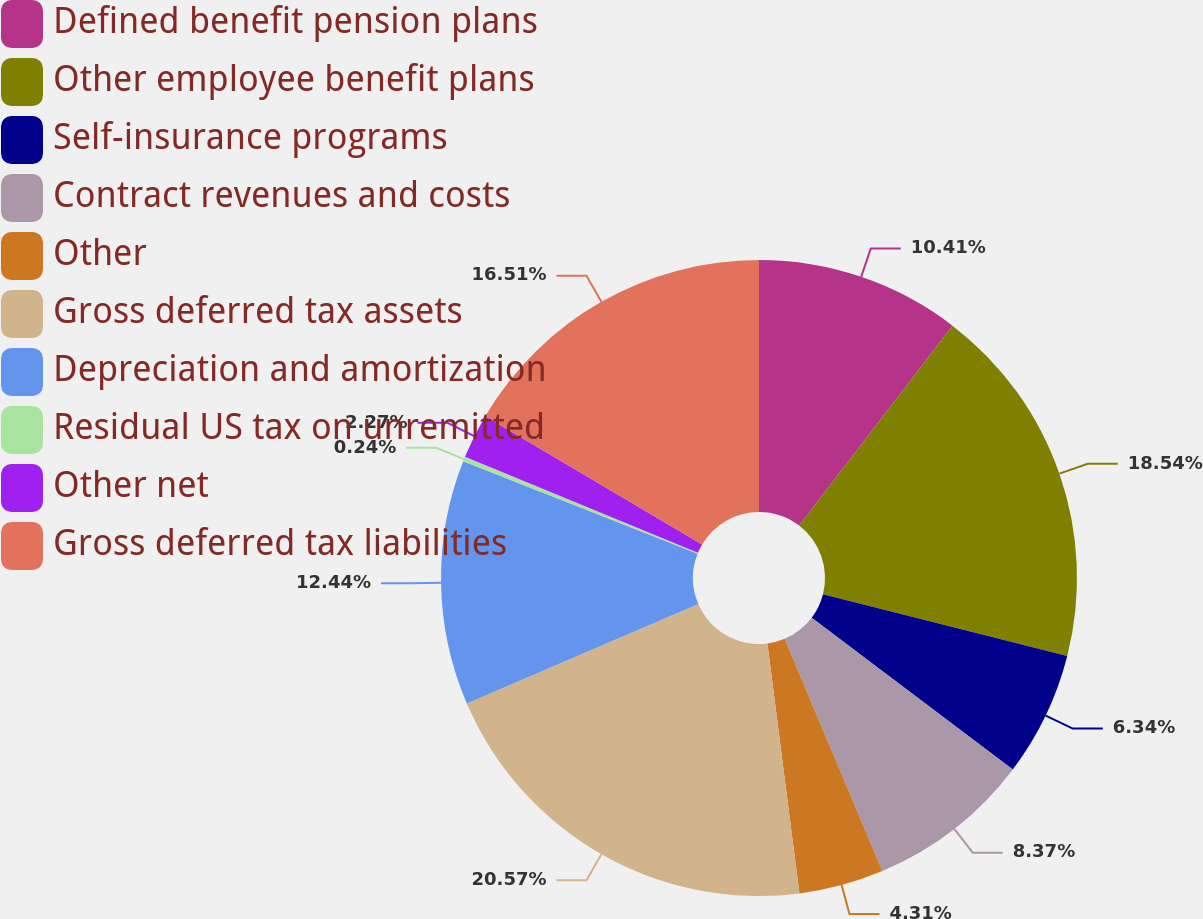Convert chart to OTSL. <chart><loc_0><loc_0><loc_500><loc_500><pie_chart><fcel>Defined benefit pension plans<fcel>Other employee benefit plans<fcel>Self-insurance programs<fcel>Contract revenues and costs<fcel>Other<fcel>Gross deferred tax assets<fcel>Depreciation and amortization<fcel>Residual US tax on unremitted<fcel>Other net<fcel>Gross deferred tax liabilities<nl><fcel>10.41%<fcel>18.54%<fcel>6.34%<fcel>8.37%<fcel>4.31%<fcel>20.57%<fcel>12.44%<fcel>0.24%<fcel>2.27%<fcel>16.51%<nl></chart> 